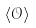<formula> <loc_0><loc_0><loc_500><loc_500>\langle { \mathcal { O } } \rangle</formula> 